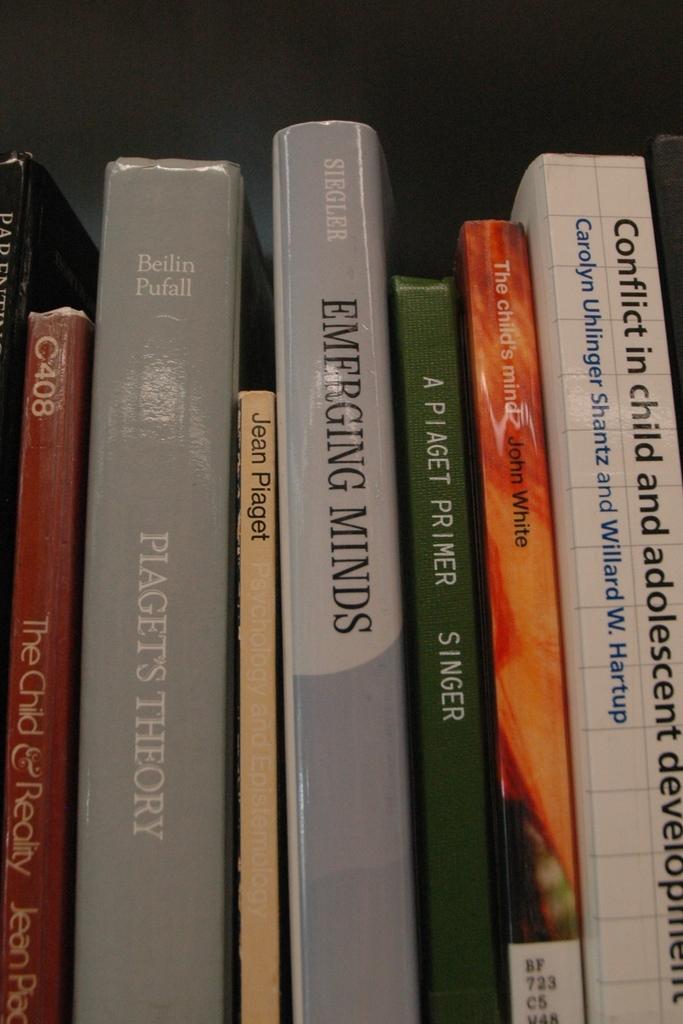What is the name of the blue book on the left?
Your answer should be very brief. Piaget's theory. 